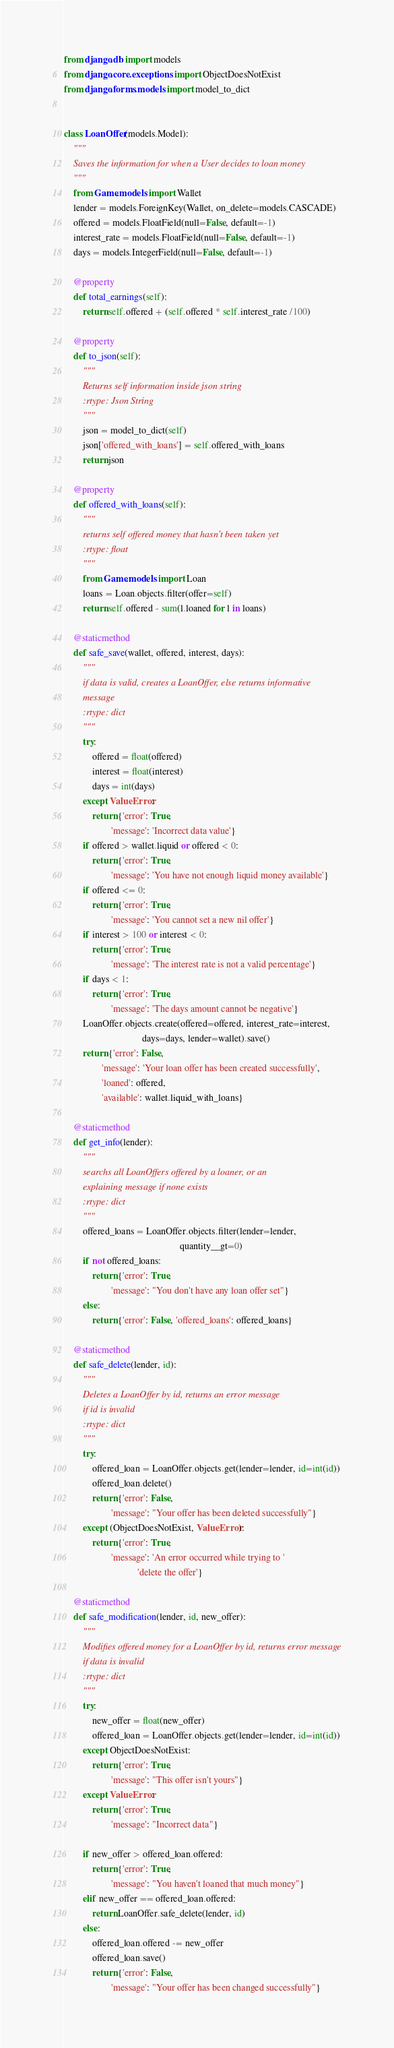Convert code to text. <code><loc_0><loc_0><loc_500><loc_500><_Python_>from django.db import models
from django.core.exceptions import ObjectDoesNotExist
from django.forms.models import model_to_dict


class LoanOffer(models.Model):
    """
    Saves the information for when a User decides to loan money
    """
    from Game.models import Wallet
    lender = models.ForeignKey(Wallet, on_delete=models.CASCADE)
    offered = models.FloatField(null=False, default=-1)
    interest_rate = models.FloatField(null=False, default=-1)
    days = models.IntegerField(null=False, default=-1)

    @property
    def total_earnings(self):
        return self.offered + (self.offered * self.interest_rate /100)

    @property
    def to_json(self):
        """
        Returns self information inside json string
        :rtype: Json String
        """
        json = model_to_dict(self)
        json['offered_with_loans'] = self.offered_with_loans
        return json

    @property
    def offered_with_loans(self):
        """
        returns self offered money that hasn't been taken yet
        :rtype: float
        """
        from Game.models import Loan
        loans = Loan.objects.filter(offer=self)
        return self.offered - sum(l.loaned for l in loans)

    @staticmethod
    def safe_save(wallet, offered, interest, days):
        """
        if data is valid, creates a LoanOffer, else returns informative
        message
        :rtype: dict
        """
        try:
            offered = float(offered)
            interest = float(interest)
            days = int(days)
        except ValueError:
            return {'error': True,
                    'message': 'Incorrect data value'}
        if offered > wallet.liquid or offered < 0:
            return {'error': True,
                    'message': 'You have not enough liquid money available'}
        if offered <= 0:
            return {'error': True,
                    'message': 'You cannot set a new nil offer'}
        if interest > 100 or interest < 0:
            return {'error': True,
                    'message': 'The interest rate is not a valid percentage'}
        if days < 1:
            return {'error': True,
                    'message': 'The days amount cannot be negative'}
        LoanOffer.objects.create(offered=offered, interest_rate=interest,
                                 days=days, lender=wallet).save()
        return {'error': False,
                'message': 'Your loan offer has been created successfully',
                'loaned': offered,
                'available': wallet.liquid_with_loans}

    @staticmethod
    def get_info(lender):
        """
        searchs all LoanOffers offered by a loaner, or an
        explaining message if none exists
        :rtype: dict
        """
        offered_loans = LoanOffer.objects.filter(lender=lender,
                                                 quantity__gt=0)
        if not offered_loans:
            return {'error': True,
                    'message': "You don't have any loan offer set"}
        else:
            return {'error': False, 'offered_loans': offered_loans}

    @staticmethod
    def safe_delete(lender, id):
        """
        Deletes a LoanOffer by id, returns an error message
        if id is invalid
        :rtype: dict
        """
        try:
            offered_loan = LoanOffer.objects.get(lender=lender, id=int(id))
            offered_loan.delete()
            return {'error': False,
                    'message': "Your offer has been deleted successfully"}
        except (ObjectDoesNotExist, ValueError):
            return {'error': True,
                    'message': 'An error occurred while trying to '
                               'delete the offer'}

    @staticmethod
    def safe_modification(lender, id, new_offer):
        """
        Modifies offered money for a LoanOffer by id, returns error message
        if data is invalid
        :rtype: dict
        """
        try:
            new_offer = float(new_offer)
            offered_loan = LoanOffer.objects.get(lender=lender, id=int(id))
        except ObjectDoesNotExist:
            return {'error': True,
                    'message': "This offer isn't yours"}
        except ValueError:
            return {'error': True,
                    'message': "Incorrect data"}

        if new_offer > offered_loan.offered:
            return {'error': True,
                    'message': "You haven't loaned that much money"}
        elif new_offer == offered_loan.offered:
            return LoanOffer.safe_delete(lender, id)
        else:
            offered_loan.offered -= new_offer
            offered_loan.save()
            return {'error': False,
                    'message': "Your offer has been changed successfully"}
</code> 